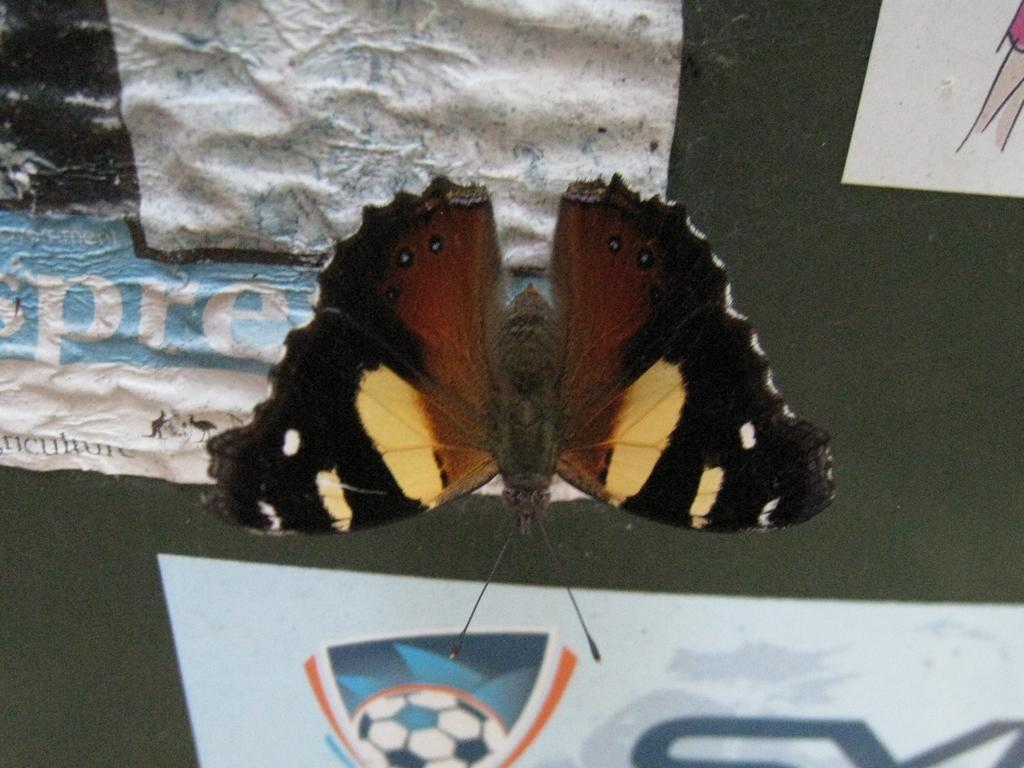What is the main subject in the center of the image? There is a butterfly in the center of the image. What can be seen in the background of the image? There is a wall and papers in the background of the image. How many sticks are being used to form the mailbox in the image? There is no mailbox or sticks present in the image. 